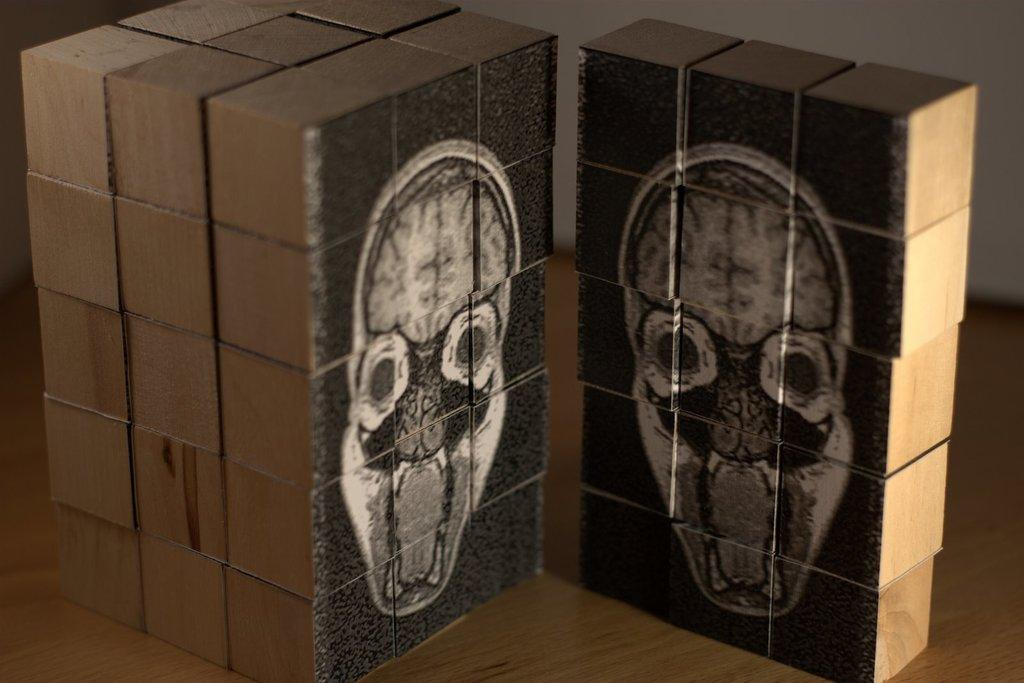What is the main object in the image? There is a wooden cube in the image. What is depicted on the wooden cube? The wooden cube has a painting of a skull on it. Is there a monkey sitting on the desk next to the wooden cube in the image? There is no mention of a monkey or a desk in the image, so we cannot confirm their presence. 